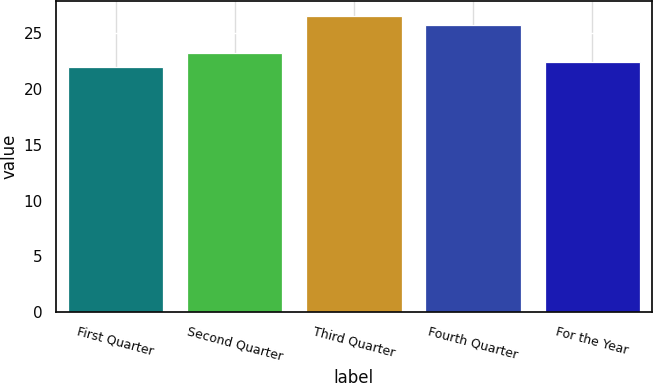<chart> <loc_0><loc_0><loc_500><loc_500><bar_chart><fcel>First Quarter<fcel>Second Quarter<fcel>Third Quarter<fcel>Fourth Quarter<fcel>For the Year<nl><fcel>21.98<fcel>23.21<fcel>26.54<fcel>25.75<fcel>22.44<nl></chart> 